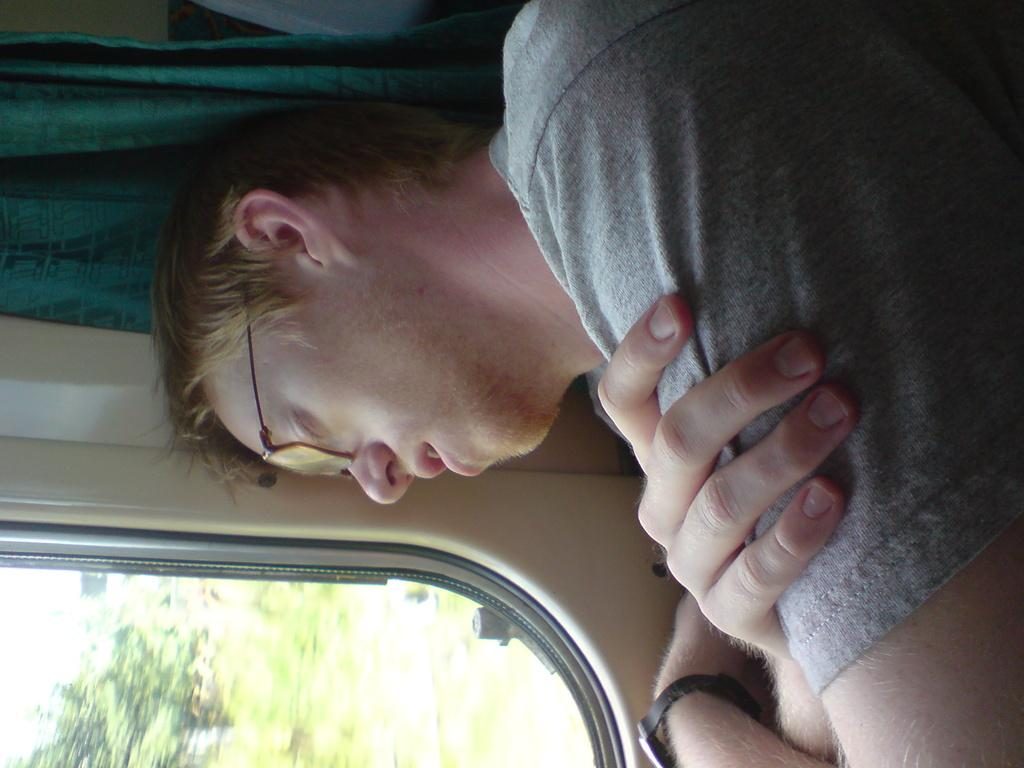Who or what is present in the image? There is a person in the image. Can you describe the person's location in relation to the window? The person is sitting beside a window. What is the person doing in the image? The person is sleeping. Which direction is the person's head facing? The person's head is laying towards the window. What type of quarter is visible in the image? There is no quarter present in the image. What color is the sky in the image? The provided facts do not mention the sky, so we cannot determine its color from the image. 